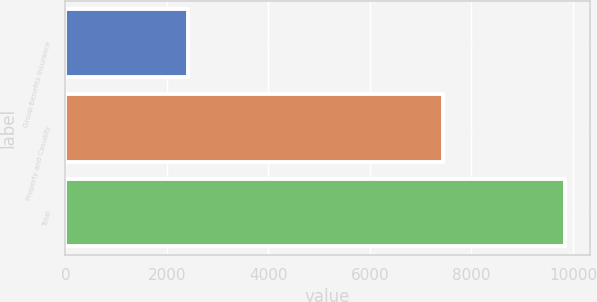Convert chart. <chart><loc_0><loc_0><loc_500><loc_500><bar_chart><fcel>Group Benefits Insurance<fcel>Property and Casualty<fcel>Total<nl><fcel>2407<fcel>7435<fcel>9842<nl></chart> 